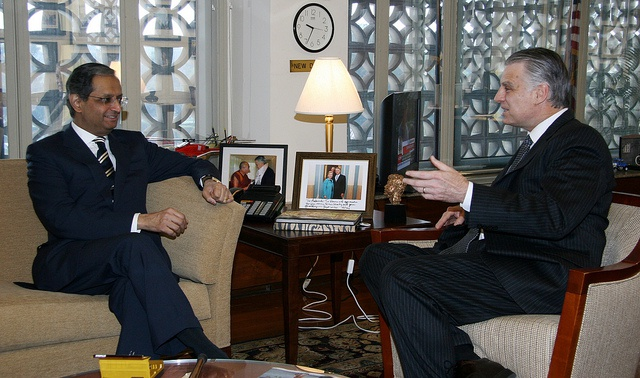Describe the objects in this image and their specific colors. I can see people in gray, black, and darkgray tones, people in gray, black, and maroon tones, couch in gray tones, chair in gray, darkgray, and maroon tones, and chair in gray, maroon, and black tones in this image. 